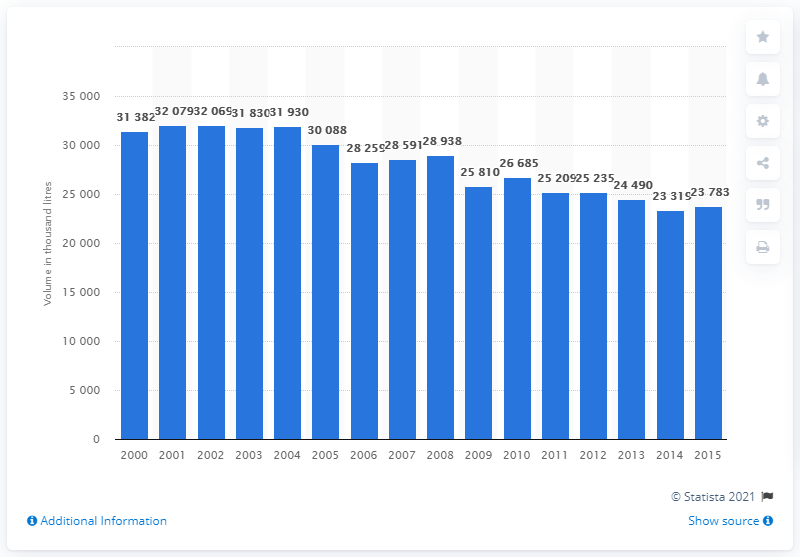Identify some key points in this picture. Since 2008, the volume of Scotch whisky released for consumption in the UK has decreased. 